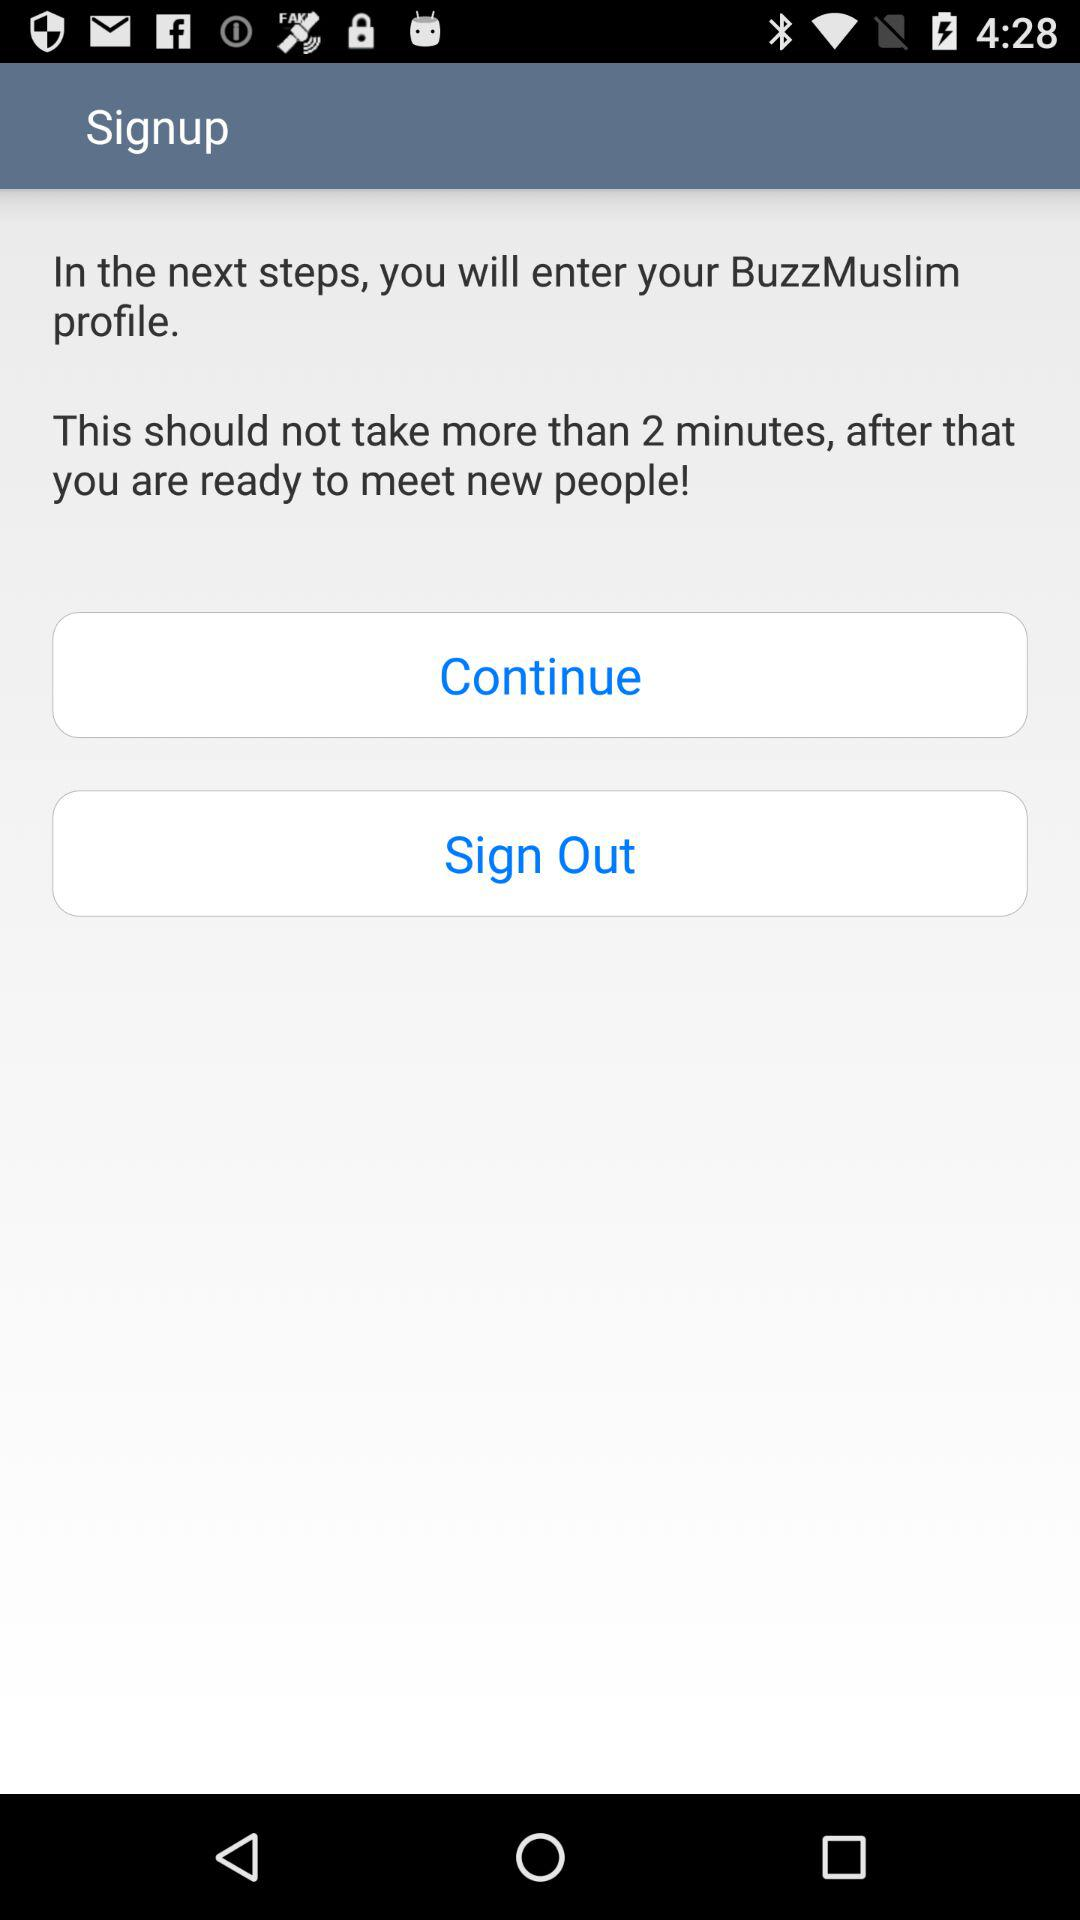What is the processing time for signing up for a "BuzzMuslim" profile? The processing time for signing up for a "BuzzMuslim" profile is 2 minutes. 